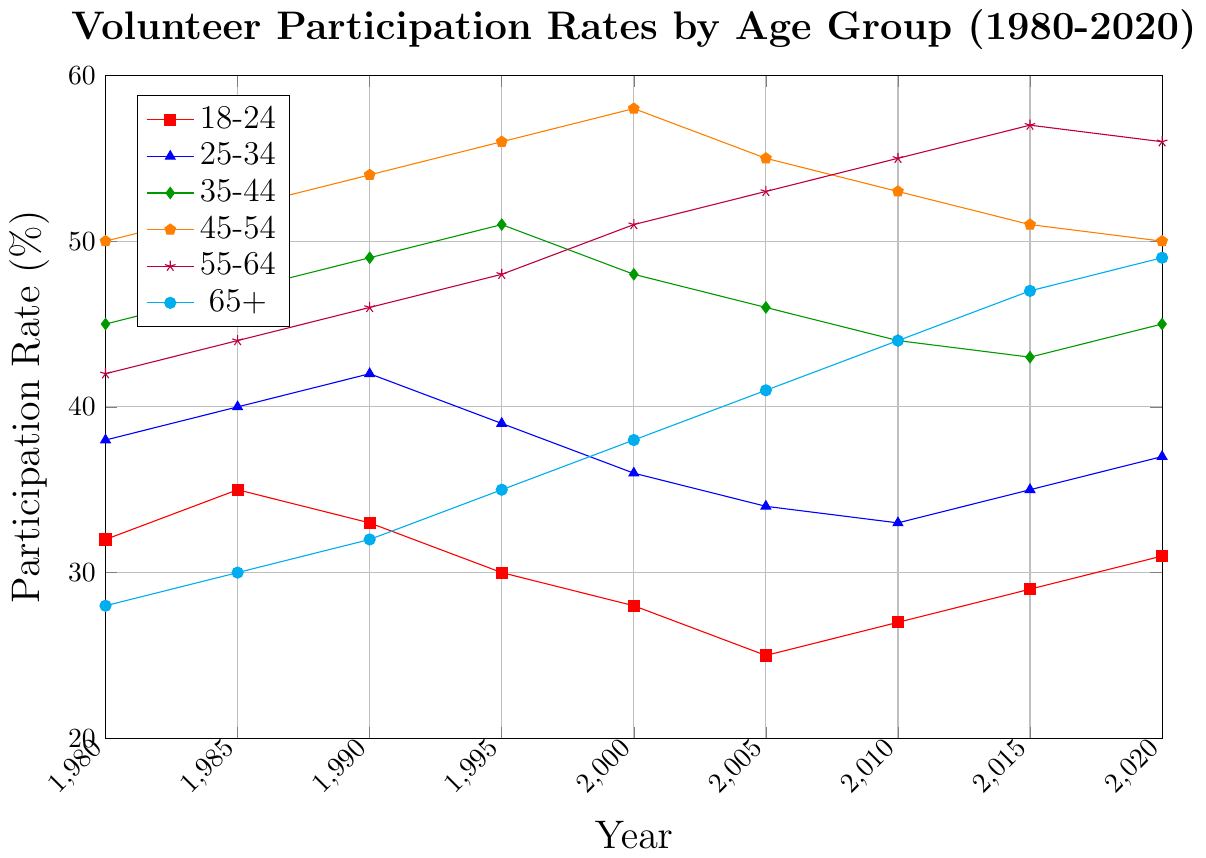What's the participation rate of the 18-24 age group in 2020? Look at the value corresponding to the 18-24 age group on the x-axis for the year 2020. The participation rate is shown by the data point at the end of the red line, which is 31.
Answer: 31% Which age group had the highest participation rate in 2000? Compare the values for the year 2000 across all age groups. The highest participation rate is associated with the 45-54 age group, which is 58%.
Answer: 45-54 How did the participation rate for the 65+ age group change from 1980 to 2020? Examine the data points for the 65+ age group in 1980 and 2020. The rate increased from 28% in 1980 to 49% in 2020. The difference is 49% - 28% = 21%.
Answer: Increased by 21% Which age group had the largest decrease in participation rate between 2000 and 2005? Calculate the differences in participation rates from 2000 to 2005 for all age groups: 
18-24: 28 - 25 = 3, 
25-34: 36 - 34 = 2, 
35-44: 48 - 46 = 2, 
45-54: 58 - 55 = 3, 
55-64: 51 - 53 = -2 (increase), 
65+: 38 - 41 = -3 (increase). 
The 18-24 and 45-54 groups had the largest decrease of 3%.
Answer: 18-24 and 45-54 What is the average participation rate of the 25-34 age group across all the years? Sum the participation rates of the 25-34 age group for all listed years and divide by the number of years: 
(38 + 40 + 42 + 39 + 36 + 34 + 33 + 35 + 37) / 9 = 37.1%.
Answer: 37.1% Between which consecutive years is the participation rate change for the 55-64 age group the greatest? Compare the differences in participation rates between consecutive years for the 55-64 age group: 
1980-1985: 44 - 42 = 2, 
1985-1990: 46 - 44 = 2, 
1990-1995: 48 - 46 = 2, 
1995-2000: 51 - 48 = 3, 
2000-2005: 53 - 51 = 2, 
2005-2010: 55 - 53 = 2, 
2010-2015: 57 - 55 = 2, 
2015-2020: 56 - 57 = -1 (decrease). The greatest change is from 1995 to 2000 with an increase of 3%.
Answer: 1995 to 2000 Which age group showed the most consistent trend in their participation rate from 1980 to 2020? Assess the overall fluctuations and trends for each age group. The 65+ group shows a consistent upward trend from 1980 to 2020 without any major drops in between.
Answer: 65+ How many age groups had a participation rate of over 40% in 1985? Check the participation rates for the year 1985 for all age groups: 
18-24: 35, 
25-34: 40, 
35-44: 47, 
45-54: 52, 
55-64: 44, 
65+: 30. 
Four age groups (25-34, 35-44, 45-54, 55-64) had over 40%.
Answer: 4 For the 25-34 age group, during which period did the participation rate remain the same? Look for periods where the participation rate for the 25-34 age group did not change between consecutive years. The rate remained 24 between 2000 and 2005 and also 33 between 2005 and 2010.
Answer: 2000 to 2005 and 2005 to 2010 What is the total change in participation rate for the 35-44 age group from 1980 to 2020? Find the participation rates for the 35-44 age group in 1980 and 2020. The difference from 1980 (45%) to 2020 (45%) is 0%.
Answer: 0% 